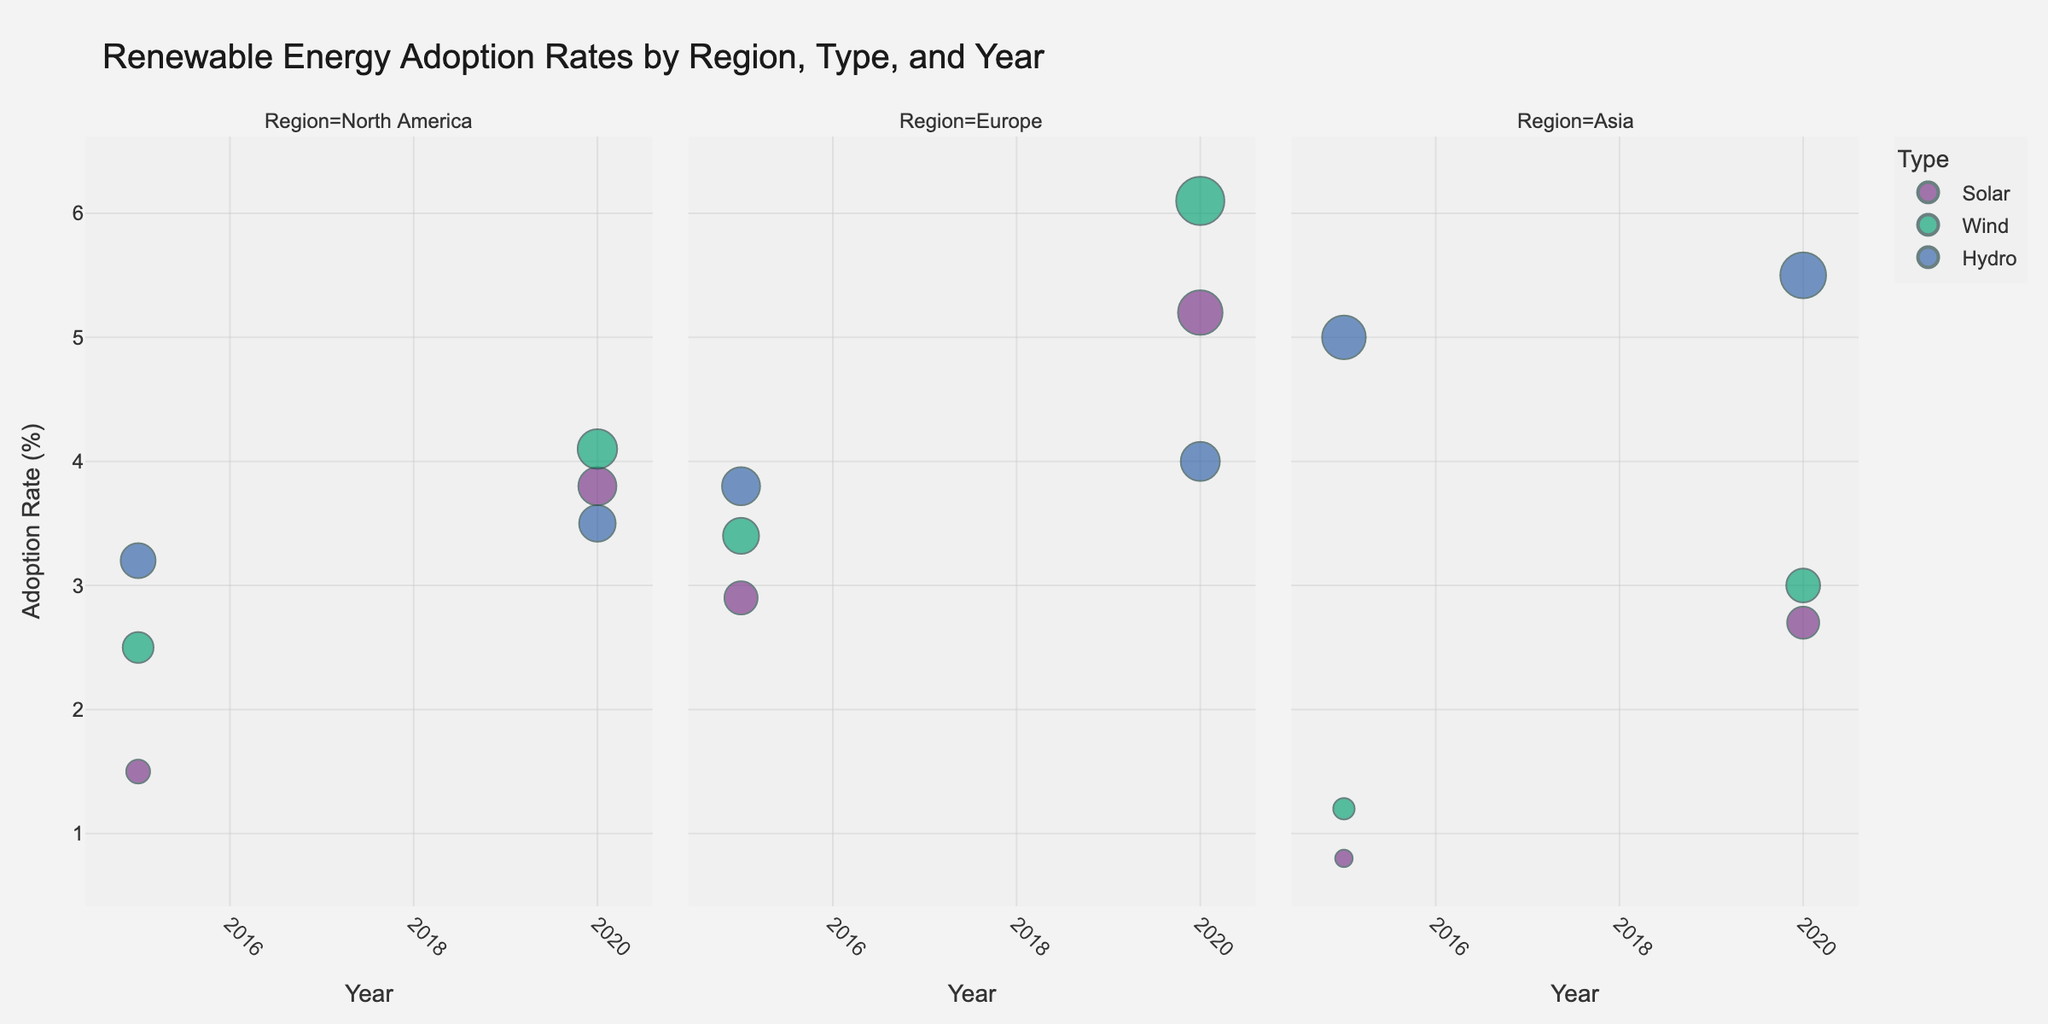What's the title of the figure? The title is usually found at the top of the figure and provides a brief summary of what the chart represents. In this case, it is clearly displayed.
Answer: Renewable Energy Adoption Rates by Region, Type, and Year How does the adoption rate of Solar energy in Europe compare between 2015 and 2020? First, locate the Solar energy bubbles for Europe in both 2015 and 2020. In 2015, the adoption rate is 2.9%, and in 2020, it is 5.2%. By comparing these two values, you can determine the rate of change.
Answer: Increased from 2.9% to 5.2% Which region had the highest Wind energy adoption rate in 2020? Look at the Wind energy bubbles for the year 2020 across all regions. The biggest bubble indicates the highest adoption rate. For Wind in 2020, Europe has the largest bubble with an adoption rate of 6.1%.
Answer: Europe What is the decrease in Hydro energy adoption rate for North America between 2015 and 2020? Locate the Hydro energy bubbles for North America in both 2015 and 2020. In 2015, the adoption rate is 3.2%, and in 2020, it is 3.5%. Calculate the difference: 3.5% - 3.2% = 0.3%.
Answer: 0.3% How many different energy types are visualized in the chart? The legend of the bubble chart shows the different energy types, each represented by a unique color. There are three types: Solar, Wind, and Hydro.
Answer: Three Which region showed the most significant increase in Solar energy adoption between 2015 and 2020? Compare the Solar energy adoption rates between 2015 and 2020 for North America, Europe, and Asia. North America went from 1.5% to 3.8%, Europe from 2.9% to 5.2%, and Asia from 0.8% to 2.7%. Calculate the difference for each: (3.8 - 1.5 = 2.3), (5.2 - 2.9 = 2.3), (2.7 - 0.8 = 1.9). Both North America and Europe increased by 2.3%, the largest increase.
Answer: North America & Europe In which year did Asia have the highest adoption rate for Hydro energy? Look at the Hydro energy bubbles for Asia in both 2015 and 2020. In 2015, the rate is 5.0%, and in 2020, it is 5.5%.
Answer: 2020 What is the total adoption rate for Wind energy in 2015 across all regions? Sum up the Wind energy adoption rates in 2015 for North America (2.5%), Europe (3.4%), and Asia (1.2%): 2.5% + 3.4% + 1.2% = 7.1%.
Answer: 7.1% Which renewable energy type has the smallest adoption rate in Europe for 2020? Examine the bubbles for Europe in 2020. Compare Solar (5.2%), Wind (6.1%), and Hydro (4.0%). Hydro has the smallest rate at 4.0%.
Answer: Hydro Does any region show a decline in adoption rates for any energy type between 2015 and 2020? Compare the 2015 and 2020 adoption rates for all energy types across all regions. North America's Hydro energy shows a slight decline from 3.2% to 3.5%, which is an increase. Thus, no energy type in any region shows a decline between 2015 and 2020.
Answer: No 